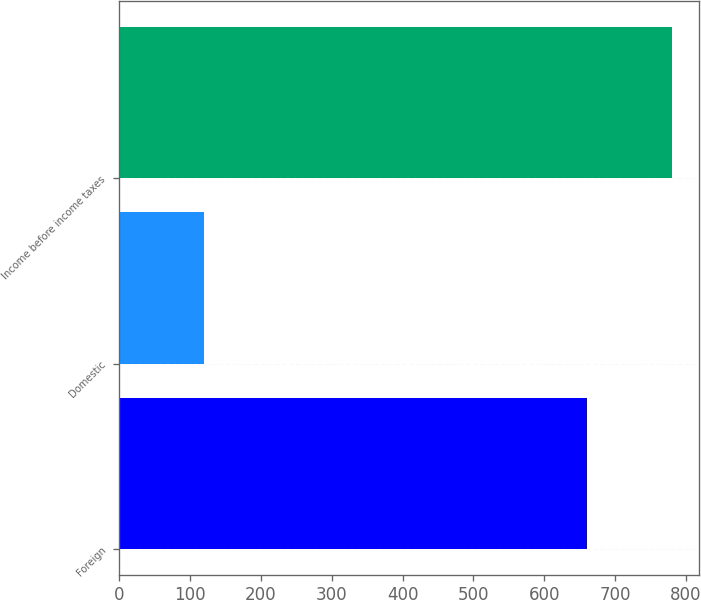Convert chart to OTSL. <chart><loc_0><loc_0><loc_500><loc_500><bar_chart><fcel>Foreign<fcel>Domestic<fcel>Income before income taxes<nl><fcel>660<fcel>120<fcel>780<nl></chart> 